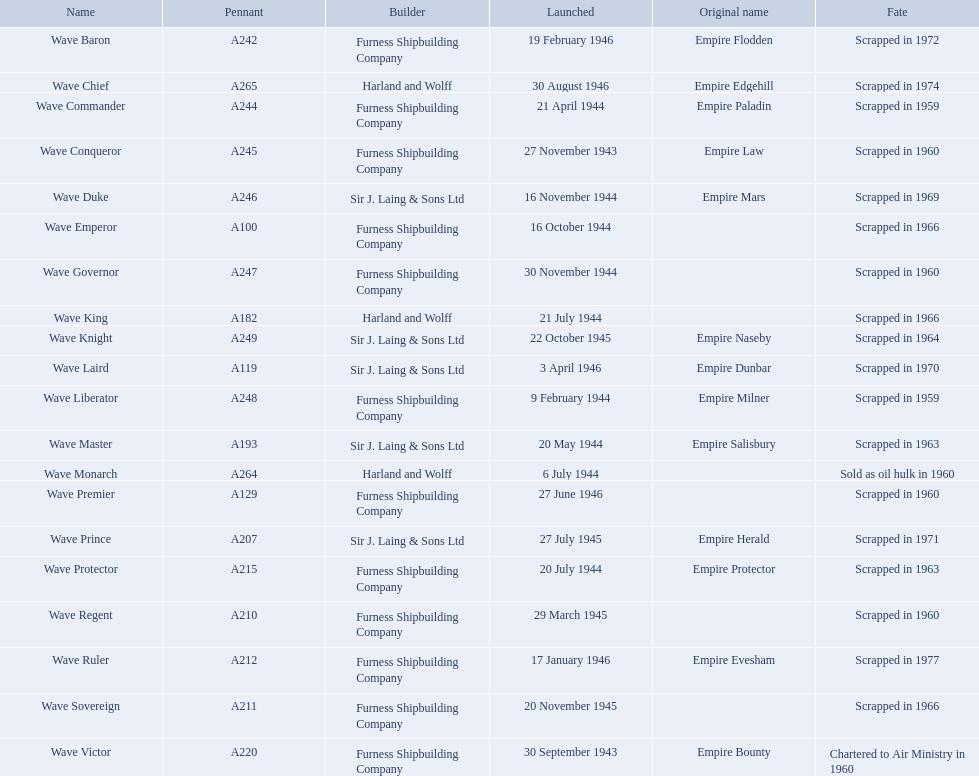What date was the wave victor launched? 30 September 1943. What other oiler was launched that same year? Wave Conqueror. Which shipbuilders set sail vessels in november of any particular year? Furness Shipbuilding Company, Sir J. Laing & Sons Ltd, Furness Shipbuilding Company, Furness Shipbuilding Company. What shipbuilder's ships had their original titles modified preceding disassembly? Furness Shipbuilding Company, Sir J. Laing & Sons Ltd. What was the name of the ship that was assembled in november and had its title changed prior to disassembly, only 12 years post its launch? Wave Conqueror. Which shipbuilders initiated ships in november of any given year? Furness Shipbuilding Company, Sir J. Laing & Sons Ltd, Furness Shipbuilding Company, Furness Shipbuilding Company. Which shipbuilders' vessels had their original names altered before being dismantled? Furness Shipbuilding Company, Sir J. Laing & Sons Ltd. What was the title of the ship constructed in november, had its name changed before being scrapped, and this occurred only 12 years after its launch? Wave Conqueror. Which shipbuilding companies launched vessels during november of any year? Furness Shipbuilding Company, Sir J. Laing & Sons Ltd, Furness Shipbuilding Company, Furness Shipbuilding Company. Which companies' ships underwent name changes prior to being disassembled? Furness Shipbuilding Company, Sir J. Laing & Sons Ltd. Can you provide the name of the ship that was completed in november, experienced a name change before scrapping, and this event happened only a dozen years after its initial launch? Wave Conqueror. 